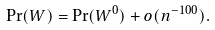Convert formula to latex. <formula><loc_0><loc_0><loc_500><loc_500>\Pr ( W ) = \Pr ( W ^ { 0 } ) + o ( n ^ { - 1 0 0 } ) .</formula> 